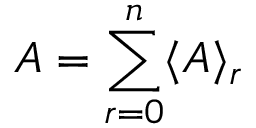Convert formula to latex. <formula><loc_0><loc_0><loc_500><loc_500>A = \sum _ { r = 0 } ^ { n } \langle A \rangle _ { r }</formula> 